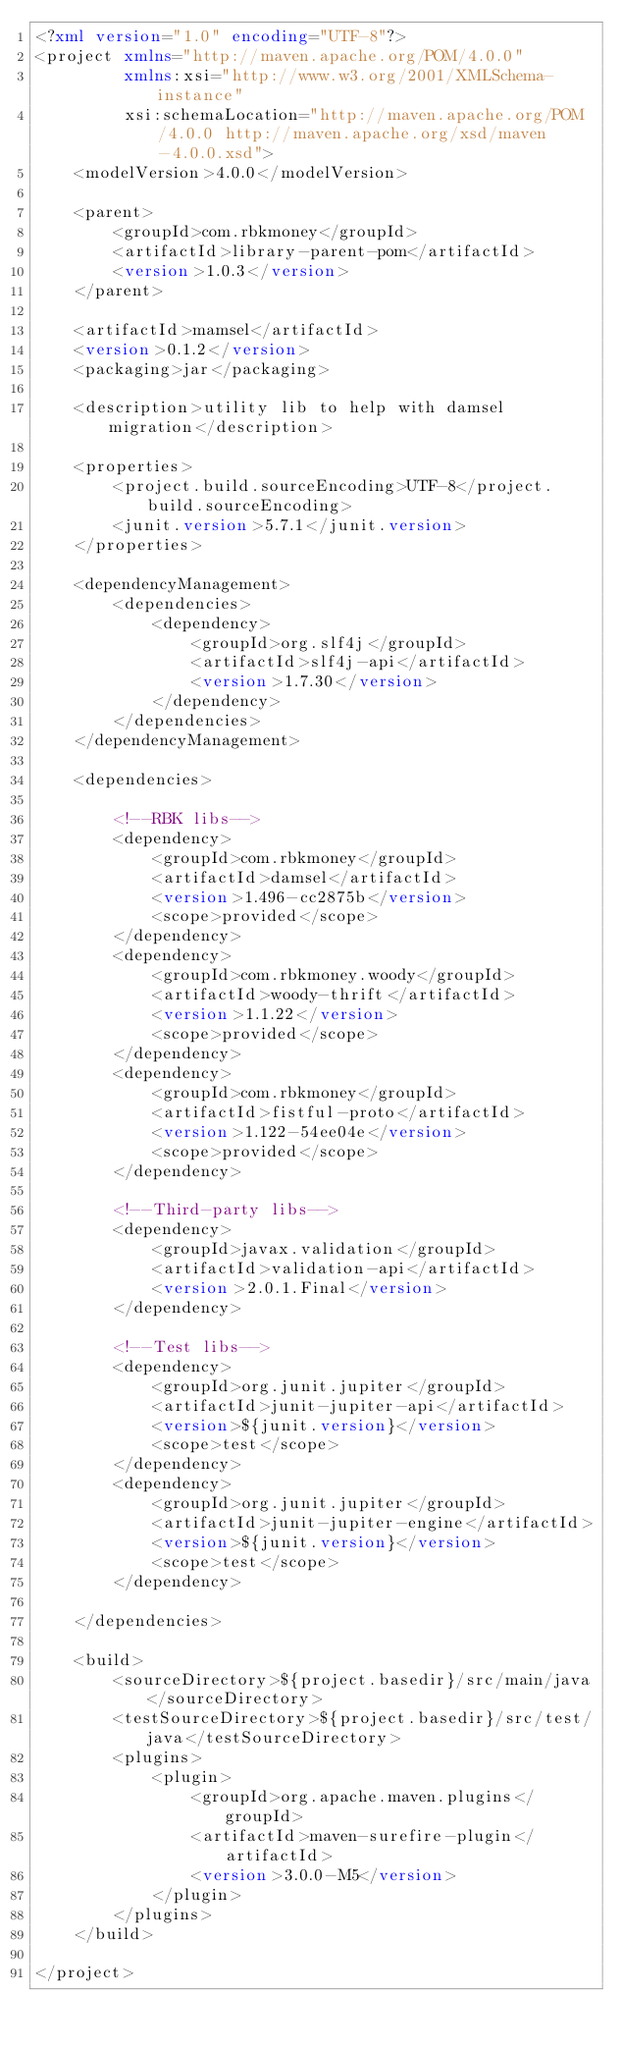<code> <loc_0><loc_0><loc_500><loc_500><_XML_><?xml version="1.0" encoding="UTF-8"?>
<project xmlns="http://maven.apache.org/POM/4.0.0"
         xmlns:xsi="http://www.w3.org/2001/XMLSchema-instance"
         xsi:schemaLocation="http://maven.apache.org/POM/4.0.0 http://maven.apache.org/xsd/maven-4.0.0.xsd">
    <modelVersion>4.0.0</modelVersion>

    <parent>
        <groupId>com.rbkmoney</groupId>
        <artifactId>library-parent-pom</artifactId>
        <version>1.0.3</version>
    </parent>

    <artifactId>mamsel</artifactId>
    <version>0.1.2</version>
    <packaging>jar</packaging>

    <description>utility lib to help with damsel migration</description>

    <properties>
        <project.build.sourceEncoding>UTF-8</project.build.sourceEncoding>
        <junit.version>5.7.1</junit.version>
    </properties>

    <dependencyManagement>
        <dependencies>
            <dependency>
                <groupId>org.slf4j</groupId>
                <artifactId>slf4j-api</artifactId>
                <version>1.7.30</version>
            </dependency>
        </dependencies>
    </dependencyManagement>

    <dependencies>

        <!--RBK libs-->
        <dependency>
            <groupId>com.rbkmoney</groupId>
            <artifactId>damsel</artifactId>
            <version>1.496-cc2875b</version>
            <scope>provided</scope>
        </dependency>
        <dependency>
            <groupId>com.rbkmoney.woody</groupId>
            <artifactId>woody-thrift</artifactId>
            <version>1.1.22</version>
            <scope>provided</scope>
        </dependency>
        <dependency>
            <groupId>com.rbkmoney</groupId>
            <artifactId>fistful-proto</artifactId>
            <version>1.122-54ee04e</version>
            <scope>provided</scope>
        </dependency>

        <!--Third-party libs-->
        <dependency>
            <groupId>javax.validation</groupId>
            <artifactId>validation-api</artifactId>
            <version>2.0.1.Final</version>
        </dependency>

        <!--Test libs-->
        <dependency>
            <groupId>org.junit.jupiter</groupId>
            <artifactId>junit-jupiter-api</artifactId>
            <version>${junit.version}</version>
            <scope>test</scope>
        </dependency>
        <dependency>
            <groupId>org.junit.jupiter</groupId>
            <artifactId>junit-jupiter-engine</artifactId>
            <version>${junit.version}</version>
            <scope>test</scope>
        </dependency>

    </dependencies>

    <build>
        <sourceDirectory>${project.basedir}/src/main/java</sourceDirectory>
        <testSourceDirectory>${project.basedir}/src/test/java</testSourceDirectory>
        <plugins>
            <plugin>
                <groupId>org.apache.maven.plugins</groupId>
                <artifactId>maven-surefire-plugin</artifactId>
                <version>3.0.0-M5</version>
            </plugin>
        </plugins>
    </build>

</project>
</code> 